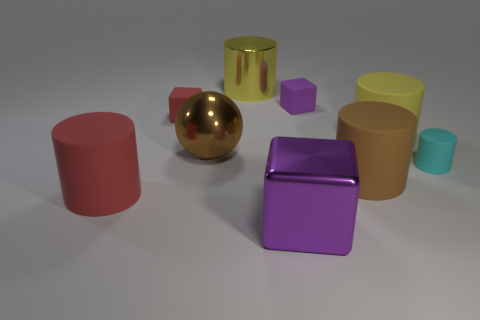Subtract all brown cylinders. How many cylinders are left? 4 Subtract all cyan rubber cylinders. How many cylinders are left? 4 Subtract all red cubes. Subtract all purple spheres. How many cubes are left? 2 Add 1 large brown things. How many objects exist? 10 Subtract all cubes. How many objects are left? 6 Add 7 green metal cubes. How many green metal cubes exist? 7 Subtract 0 cyan blocks. How many objects are left? 9 Subtract all tiny red rubber things. Subtract all big red cylinders. How many objects are left? 7 Add 8 small red matte objects. How many small red matte objects are left? 9 